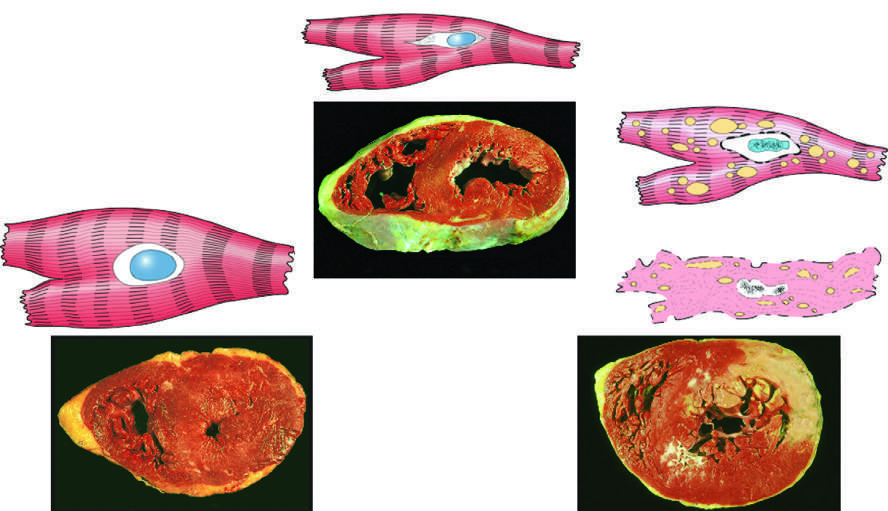what is hypertrophy?
Answer the question using a single word or phrase. The cellular adaptation depicted here 